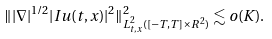<formula> <loc_0><loc_0><loc_500><loc_500>\| | \nabla | ^ { 1 / 2 } | I u ( t , x ) | ^ { 2 } \| _ { L _ { t , x } ^ { 2 } ( [ - T , T ] \times R ^ { 2 } ) } ^ { 2 } \lesssim o ( K ) .</formula> 